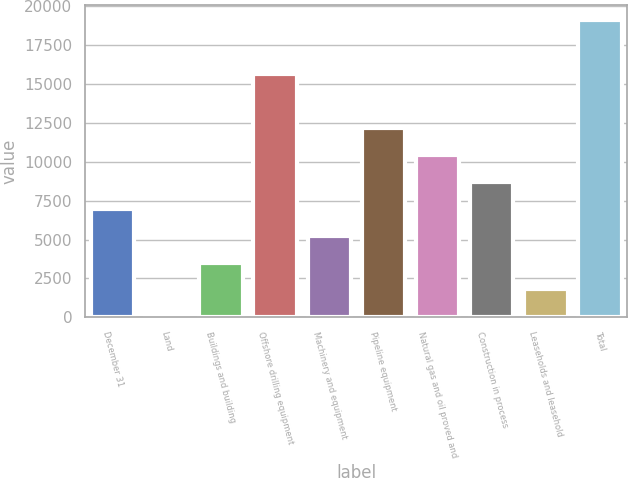<chart> <loc_0><loc_0><loc_500><loc_500><bar_chart><fcel>December 31<fcel>Land<fcel>Buildings and building<fcel>Offshore drilling equipment<fcel>Machinery and equipment<fcel>Pipeline equipment<fcel>Natural gas and oil proved and<fcel>Construction in process<fcel>Leaseholds and leasehold<fcel>Total<nl><fcel>6976.8<fcel>70<fcel>3523.4<fcel>15610.3<fcel>5250.1<fcel>12156.9<fcel>10430.2<fcel>8703.5<fcel>1796.7<fcel>19063.7<nl></chart> 